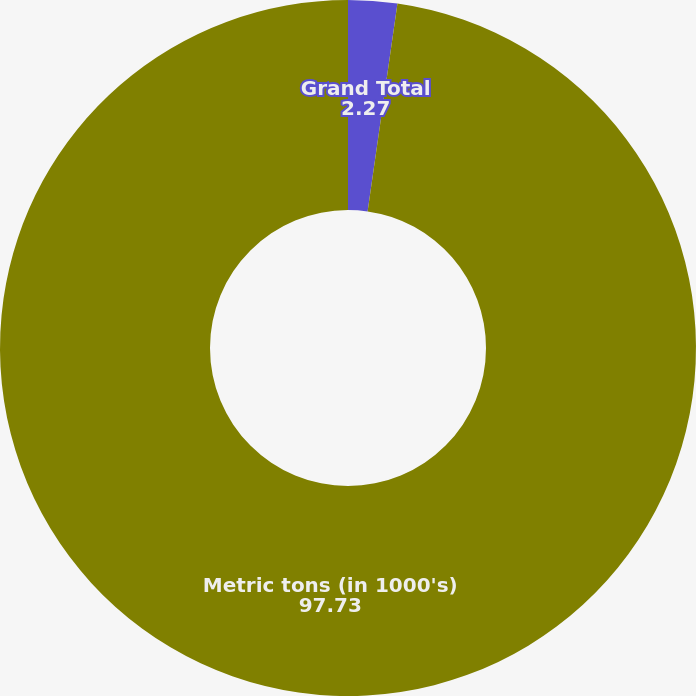Convert chart to OTSL. <chart><loc_0><loc_0><loc_500><loc_500><pie_chart><fcel>Grand Total<fcel>Metric tons (in 1000's)<nl><fcel>2.27%<fcel>97.73%<nl></chart> 